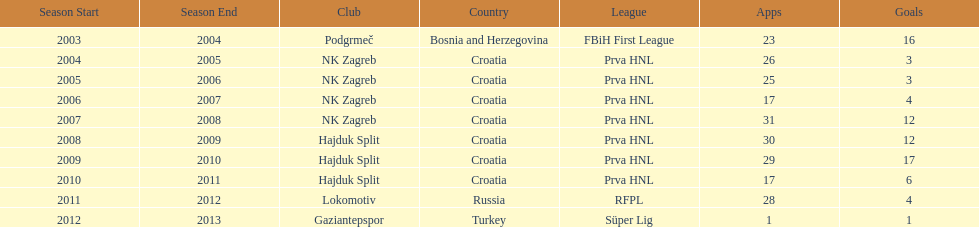The team with the most goals Hajduk Split. Could you parse the entire table as a dict? {'header': ['Season Start', 'Season End', 'Club', 'Country', 'League', 'Apps', 'Goals'], 'rows': [['2003', '2004', 'Podgrmeč', 'Bosnia and Herzegovina', 'FBiH First League', '23', '16'], ['2004', '2005', 'NK Zagreb', 'Croatia', 'Prva HNL', '26', '3'], ['2005', '2006', 'NK Zagreb', 'Croatia', 'Prva HNL', '25', '3'], ['2006', '2007', 'NK Zagreb', 'Croatia', 'Prva HNL', '17', '4'], ['2007', '2008', 'NK Zagreb', 'Croatia', 'Prva HNL', '31', '12'], ['2008', '2009', 'Hajduk Split', 'Croatia', 'Prva HNL', '30', '12'], ['2009', '2010', 'Hajduk Split', 'Croatia', 'Prva HNL', '29', '17'], ['2010', '2011', 'Hajduk Split', 'Croatia', 'Prva HNL', '17', '6'], ['2011', '2012', 'Lokomotiv', 'Russia', 'RFPL', '28', '4'], ['2012', '2013', 'Gaziantepspor', 'Turkey', 'Süper Lig', '1', '1']]} 